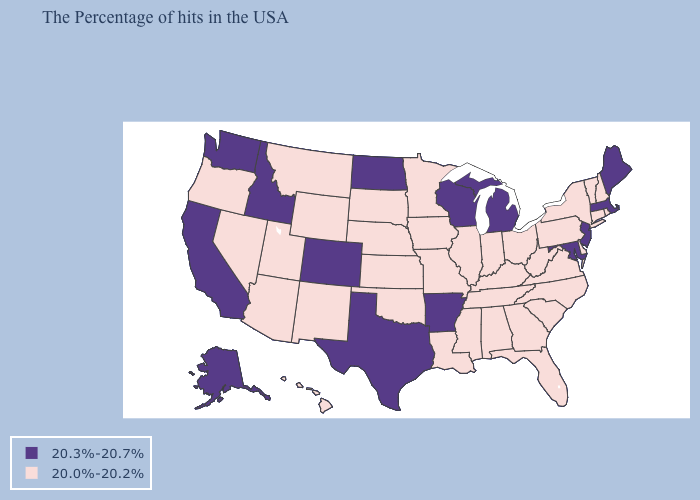Name the states that have a value in the range 20.0%-20.2%?
Give a very brief answer. Rhode Island, New Hampshire, Vermont, Connecticut, New York, Delaware, Pennsylvania, Virginia, North Carolina, South Carolina, West Virginia, Ohio, Florida, Georgia, Kentucky, Indiana, Alabama, Tennessee, Illinois, Mississippi, Louisiana, Missouri, Minnesota, Iowa, Kansas, Nebraska, Oklahoma, South Dakota, Wyoming, New Mexico, Utah, Montana, Arizona, Nevada, Oregon, Hawaii. Does Arkansas have a higher value than South Carolina?
Concise answer only. Yes. What is the highest value in the West ?
Give a very brief answer. 20.3%-20.7%. What is the lowest value in the USA?
Keep it brief. 20.0%-20.2%. What is the highest value in states that border Maryland?
Concise answer only. 20.0%-20.2%. What is the value of Indiana?
Concise answer only. 20.0%-20.2%. What is the lowest value in the USA?
Answer briefly. 20.0%-20.2%. What is the value of New Hampshire?
Short answer required. 20.0%-20.2%. Name the states that have a value in the range 20.0%-20.2%?
Be succinct. Rhode Island, New Hampshire, Vermont, Connecticut, New York, Delaware, Pennsylvania, Virginia, North Carolina, South Carolina, West Virginia, Ohio, Florida, Georgia, Kentucky, Indiana, Alabama, Tennessee, Illinois, Mississippi, Louisiana, Missouri, Minnesota, Iowa, Kansas, Nebraska, Oklahoma, South Dakota, Wyoming, New Mexico, Utah, Montana, Arizona, Nevada, Oregon, Hawaii. Does Kansas have the same value as North Carolina?
Short answer required. Yes. Name the states that have a value in the range 20.3%-20.7%?
Concise answer only. Maine, Massachusetts, New Jersey, Maryland, Michigan, Wisconsin, Arkansas, Texas, North Dakota, Colorado, Idaho, California, Washington, Alaska. What is the value of Nebraska?
Concise answer only. 20.0%-20.2%. Which states have the lowest value in the West?
Concise answer only. Wyoming, New Mexico, Utah, Montana, Arizona, Nevada, Oregon, Hawaii. What is the value of Alaska?
Concise answer only. 20.3%-20.7%. Does Louisiana have the lowest value in the South?
Give a very brief answer. Yes. 